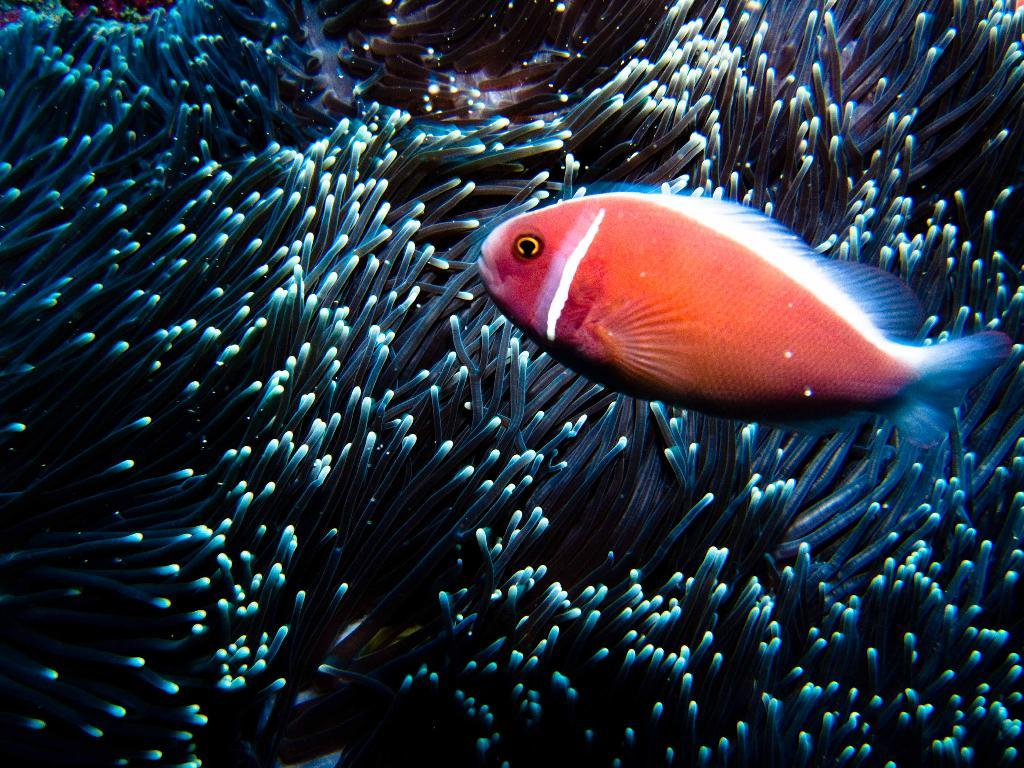What is happening in the water in the image? There is a dip in the water in the image. What type of vegetation can be seen in the water? There are water plants in the image. Can you describe the fish in the image? There is an orange fish with a white line in the image. What type of government can be seen in the image? There is no government present in the image; it features a dip in the water, water plants, and a fish. What type of laborer is working in the image? There is no laborer present in the image; it features a dip in the water, water plants, and a fish. 